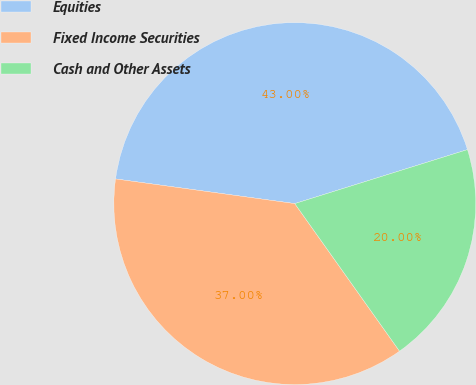Convert chart to OTSL. <chart><loc_0><loc_0><loc_500><loc_500><pie_chart><fcel>Equities<fcel>Fixed Income Securities<fcel>Cash and Other Assets<nl><fcel>43.0%<fcel>37.0%<fcel>20.0%<nl></chart> 